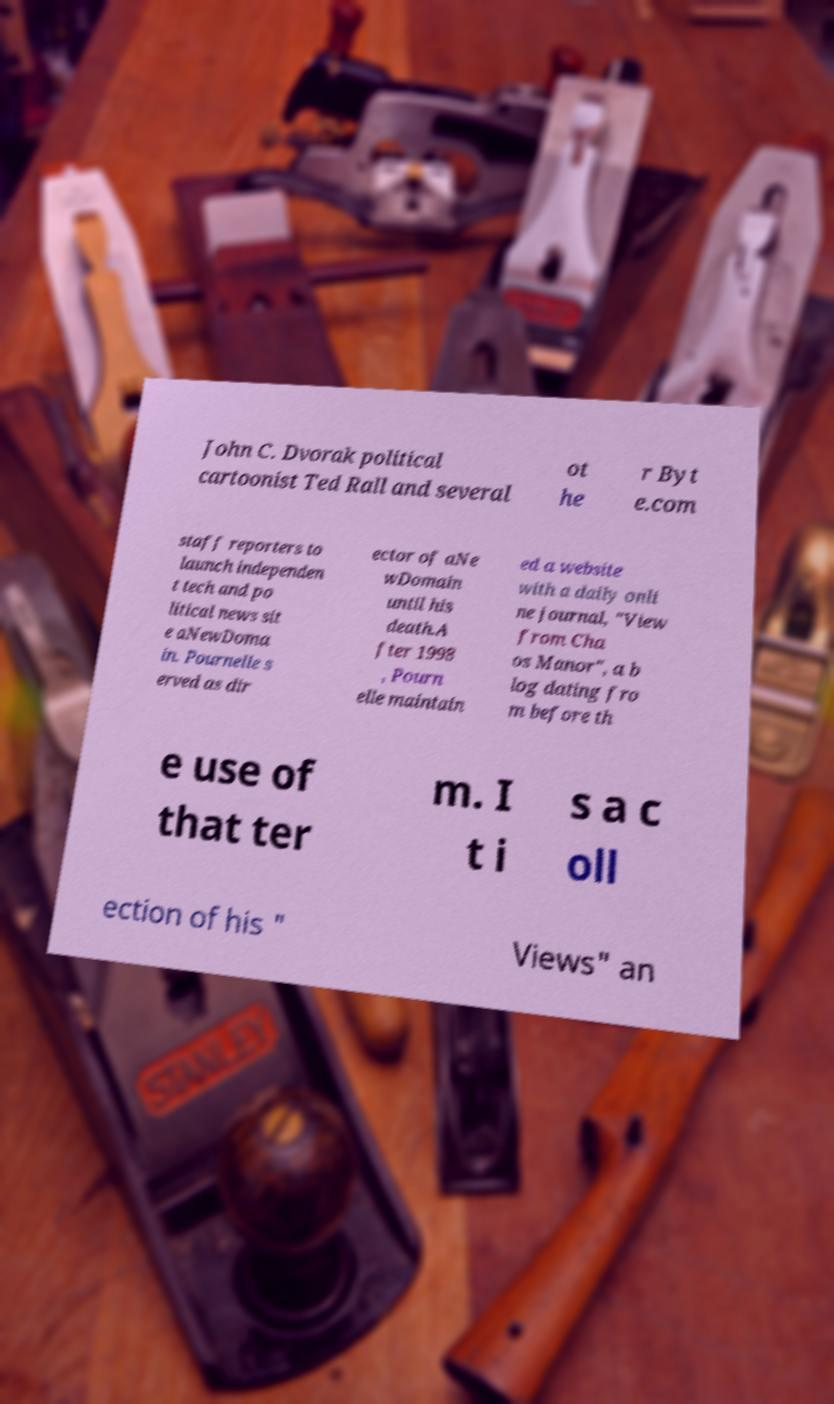What messages or text are displayed in this image? I need them in a readable, typed format. John C. Dvorak political cartoonist Ted Rall and several ot he r Byt e.com staff reporters to launch independen t tech and po litical news sit e aNewDoma in. Pournelle s erved as dir ector of aNe wDomain until his death.A fter 1998 , Pourn elle maintain ed a website with a daily onli ne journal, "View from Cha os Manor", a b log dating fro m before th e use of that ter m. I t i s a c oll ection of his " Views" an 